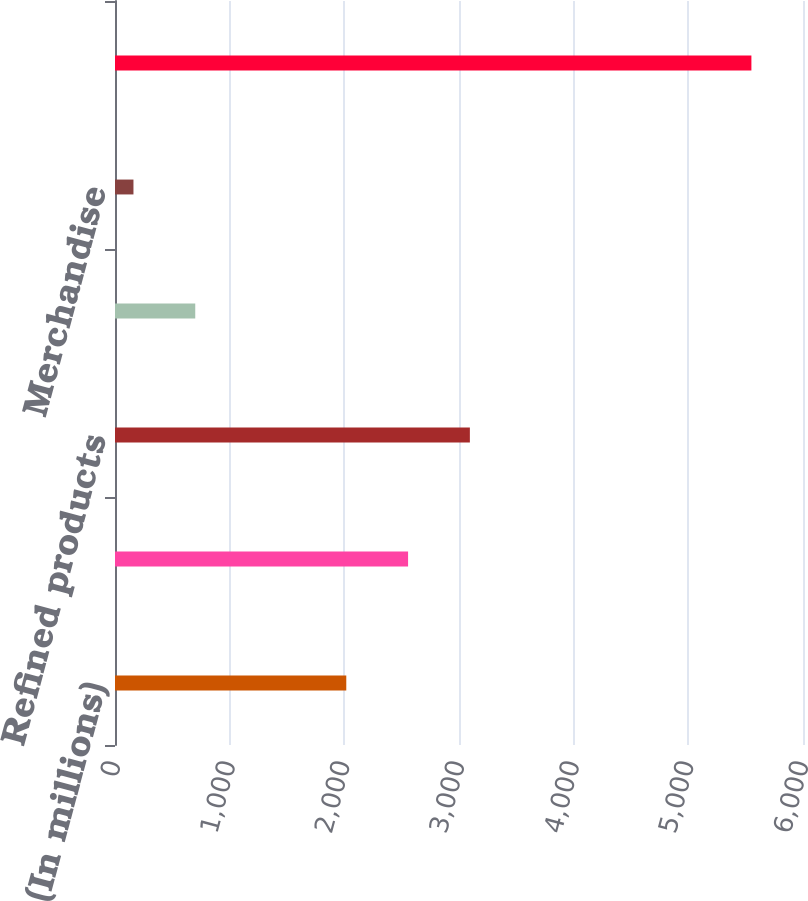Convert chart. <chart><loc_0><loc_0><loc_500><loc_500><bar_chart><fcel>(In millions)<fcel>Crude oil and refinery<fcel>Refined products<fcel>Materials and supplies<fcel>Merchandise<fcel>Total<nl><fcel>2017<fcel>2555.9<fcel>3094.8<fcel>699.9<fcel>161<fcel>5550<nl></chart> 